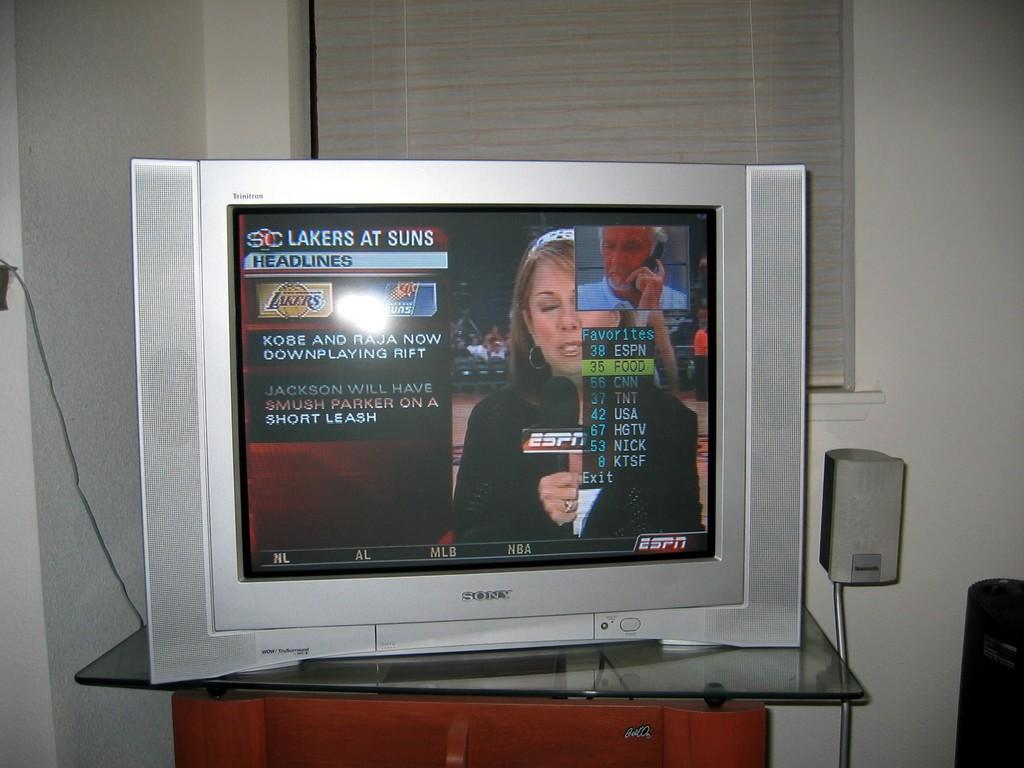Who is playing at suns?
Your answer should be compact. Lakers. What is being watched on tv?
Make the answer very short. Lakers at suns. 